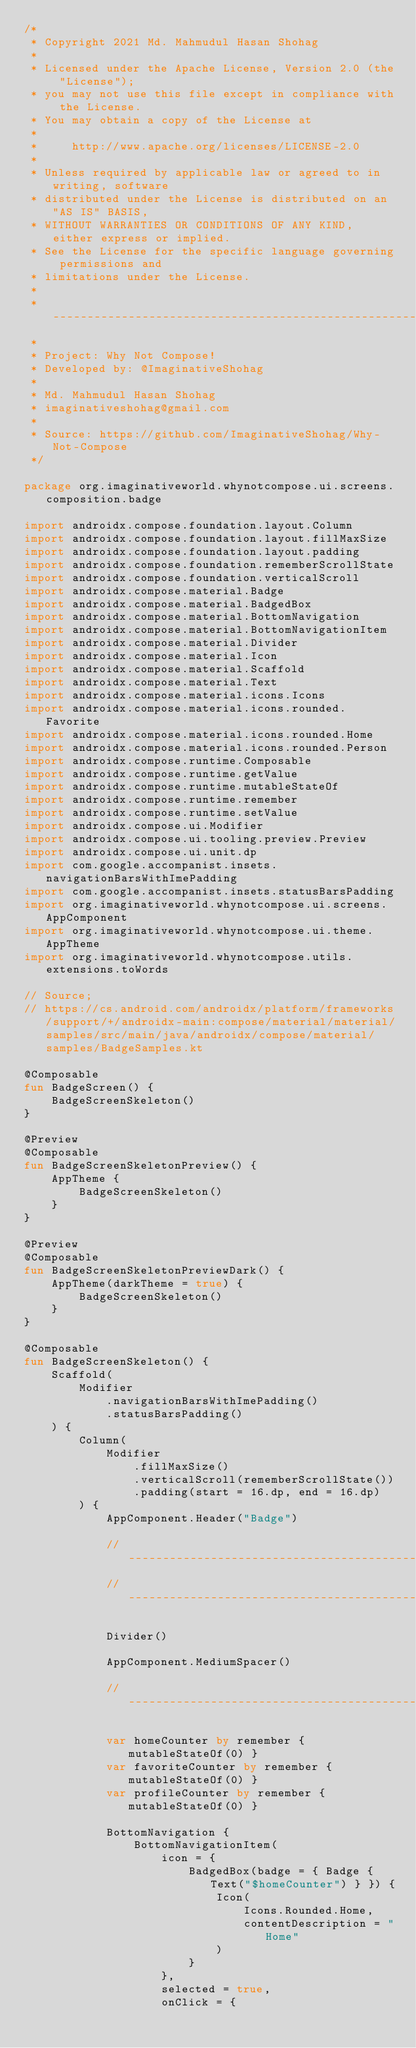Convert code to text. <code><loc_0><loc_0><loc_500><loc_500><_Kotlin_>/*
 * Copyright 2021 Md. Mahmudul Hasan Shohag
 *
 * Licensed under the Apache License, Version 2.0 (the "License");
 * you may not use this file except in compliance with the License.
 * You may obtain a copy of the License at
 *
 *     http://www.apache.org/licenses/LICENSE-2.0
 *
 * Unless required by applicable law or agreed to in writing, software
 * distributed under the License is distributed on an "AS IS" BASIS,
 * WITHOUT WARRANTIES OR CONDITIONS OF ANY KIND, either express or implied.
 * See the License for the specific language governing permissions and
 * limitations under the License.
 *
 * ------------------------------------------------------------------------
 *
 * Project: Why Not Compose!
 * Developed by: @ImaginativeShohag
 *
 * Md. Mahmudul Hasan Shohag
 * imaginativeshohag@gmail.com
 *
 * Source: https://github.com/ImaginativeShohag/Why-Not-Compose
 */

package org.imaginativeworld.whynotcompose.ui.screens.composition.badge

import androidx.compose.foundation.layout.Column
import androidx.compose.foundation.layout.fillMaxSize
import androidx.compose.foundation.layout.padding
import androidx.compose.foundation.rememberScrollState
import androidx.compose.foundation.verticalScroll
import androidx.compose.material.Badge
import androidx.compose.material.BadgedBox
import androidx.compose.material.BottomNavigation
import androidx.compose.material.BottomNavigationItem
import androidx.compose.material.Divider
import androidx.compose.material.Icon
import androidx.compose.material.Scaffold
import androidx.compose.material.Text
import androidx.compose.material.icons.Icons
import androidx.compose.material.icons.rounded.Favorite
import androidx.compose.material.icons.rounded.Home
import androidx.compose.material.icons.rounded.Person
import androidx.compose.runtime.Composable
import androidx.compose.runtime.getValue
import androidx.compose.runtime.mutableStateOf
import androidx.compose.runtime.remember
import androidx.compose.runtime.setValue
import androidx.compose.ui.Modifier
import androidx.compose.ui.tooling.preview.Preview
import androidx.compose.ui.unit.dp
import com.google.accompanist.insets.navigationBarsWithImePadding
import com.google.accompanist.insets.statusBarsPadding
import org.imaginativeworld.whynotcompose.ui.screens.AppComponent
import org.imaginativeworld.whynotcompose.ui.theme.AppTheme
import org.imaginativeworld.whynotcompose.utils.extensions.toWords

// Source;
// https://cs.android.com/androidx/platform/frameworks/support/+/androidx-main:compose/material/material/samples/src/main/java/androidx/compose/material/samples/BadgeSamples.kt

@Composable
fun BadgeScreen() {
    BadgeScreenSkeleton()
}

@Preview
@Composable
fun BadgeScreenSkeletonPreview() {
    AppTheme {
        BadgeScreenSkeleton()
    }
}

@Preview
@Composable
fun BadgeScreenSkeletonPreviewDark() {
    AppTheme(darkTheme = true) {
        BadgeScreenSkeleton()
    }
}

@Composable
fun BadgeScreenSkeleton() {
    Scaffold(
        Modifier
            .navigationBarsWithImePadding()
            .statusBarsPadding()
    ) {
        Column(
            Modifier
                .fillMaxSize()
                .verticalScroll(rememberScrollState())
                .padding(start = 16.dp, end = 16.dp)
        ) {
            AppComponent.Header("Badge")

            // ----------------------------------------------------------------
            // ----------------------------------------------------------------

            Divider()

            AppComponent.MediumSpacer()

            // ----------------------------------------------------------------

            var homeCounter by remember { mutableStateOf(0) }
            var favoriteCounter by remember { mutableStateOf(0) }
            var profileCounter by remember { mutableStateOf(0) }

            BottomNavigation {
                BottomNavigationItem(
                    icon = {
                        BadgedBox(badge = { Badge { Text("$homeCounter") } }) {
                            Icon(
                                Icons.Rounded.Home,
                                contentDescription = "Home"
                            )
                        }
                    },
                    selected = true,
                    onClick = {</code> 